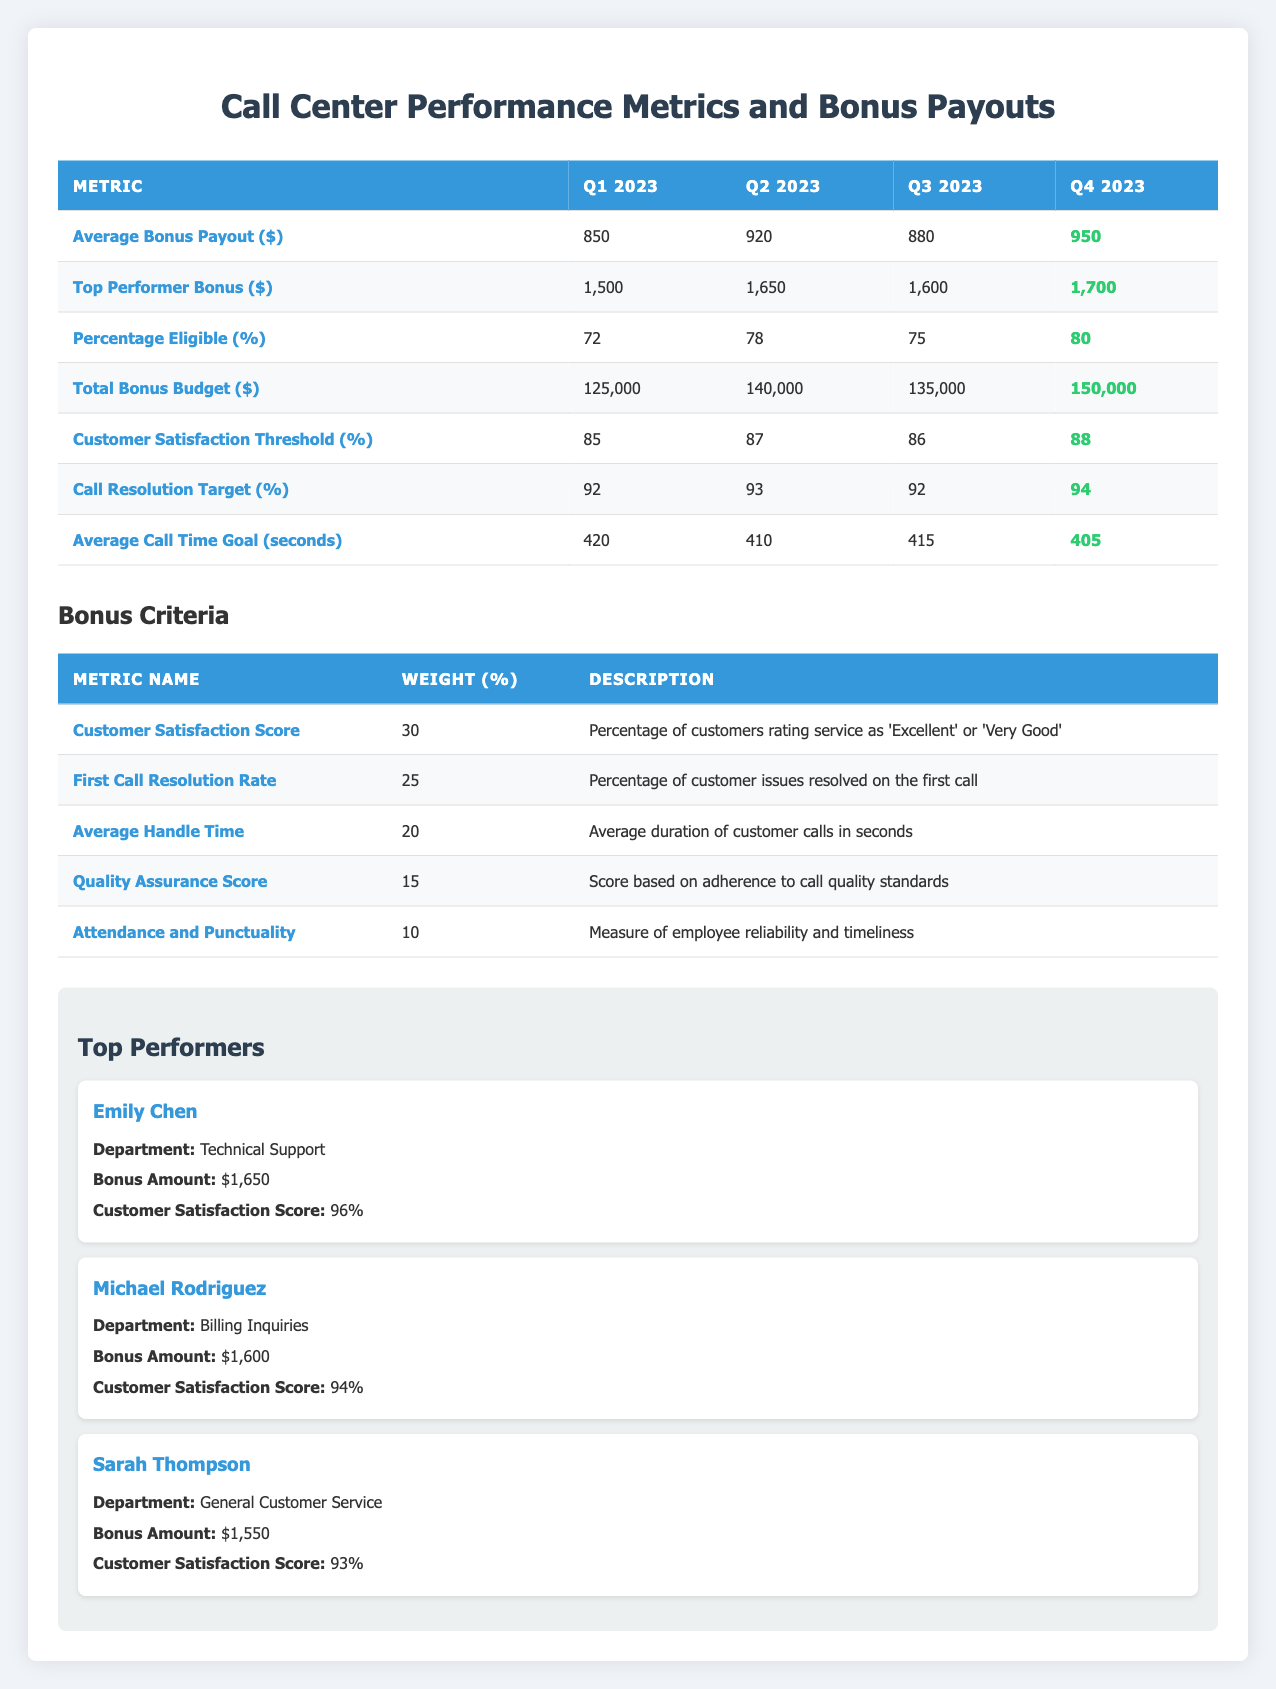What was the average bonus payout in Q2 2023? In the table, under the Q2 2023 column, the row for Average Bonus Payout shows 920.
Answer: 920 What is the highest bonus amount for a top performer in Q4 2023? The table indicates that the Top Performer Bonus in Q4 2023 is 1700.
Answer: 1700 Was the percentage of eligible representatives greater in Q1 or Q3 2023? The percentage eligible in Q1 2023 is 72, while in Q3 2023 it is 75. Since 75 is greater than 72, Q3 has a higher percentage eligible.
Answer: Yes What is the total bonus budget for all four quarters? To find the total bonus budget, add the values for each quarter: 125000 (Q1) + 140000 (Q2) + 135000 (Q3) + 150000 (Q4) = 550000.
Answer: 550000 Did the average call time goal decrease from Q1 to Q4 2023? The average call time goal in Q1 2023 is 420 seconds, and in Q4 2023 it is 405 seconds. Since 405 is less than 420, this shows a decrease.
Answer: Yes What was the change in the call resolution target from Q2 2023 to Q4 2023? In Q2 2023, the call resolution target is 93, and in Q4 2023 it is 94. The change is calculated as 94 - 93 = 1, an increase of 1 percentage point.
Answer: 1 Which quarter had the highest customer satisfaction threshold? By observing the table, the customer satisfaction threshold for Q4 2023 is 88, which is higher than the values for the other quarters: 85 (Q1), 87 (Q2), and 86 (Q3).
Answer: Q4 2023 What is the weight of Attendance and Punctuality in the bonus criteria? The weight for Attendance and Punctuality is shown in the table as 10.
Answer: 10 Did the average bonus payout increase from Q1 to Q3 2023? In Q1 2023, the average bonus payout is 850, and in Q3 2023 it is 880. Since 880 is greater than 850, it did increase.
Answer: Yes 